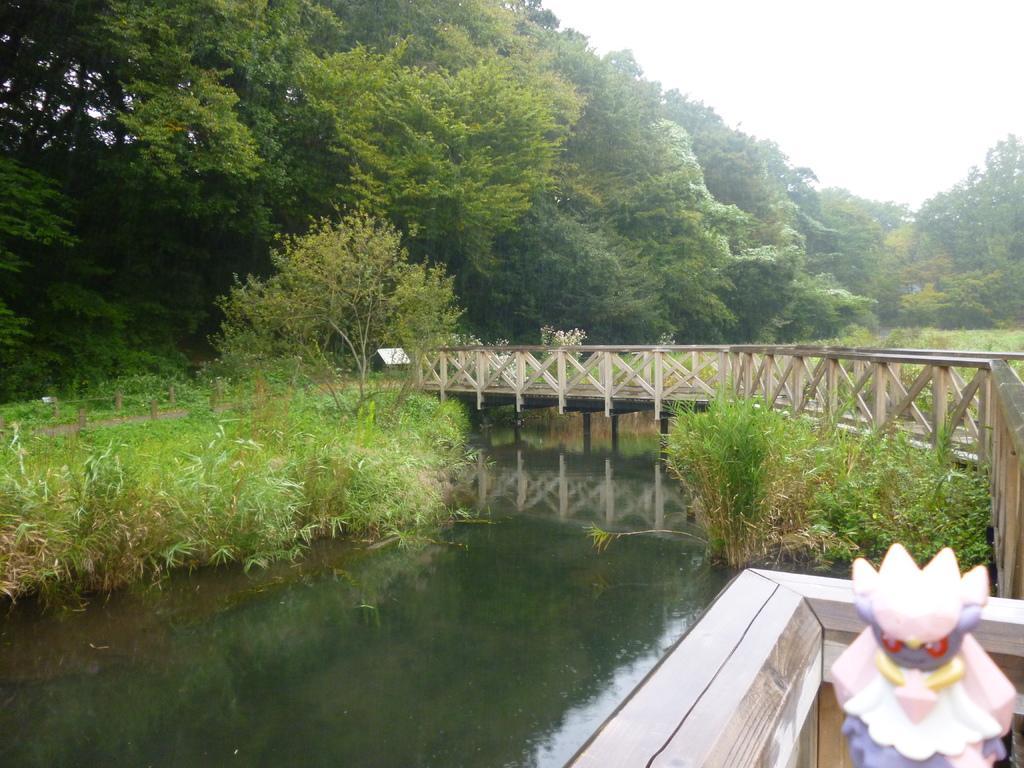How would you summarize this image in a sentence or two? In this picture we can see the water, bridge, toy, plants, trees, some objects and in the background we can see the sky. 